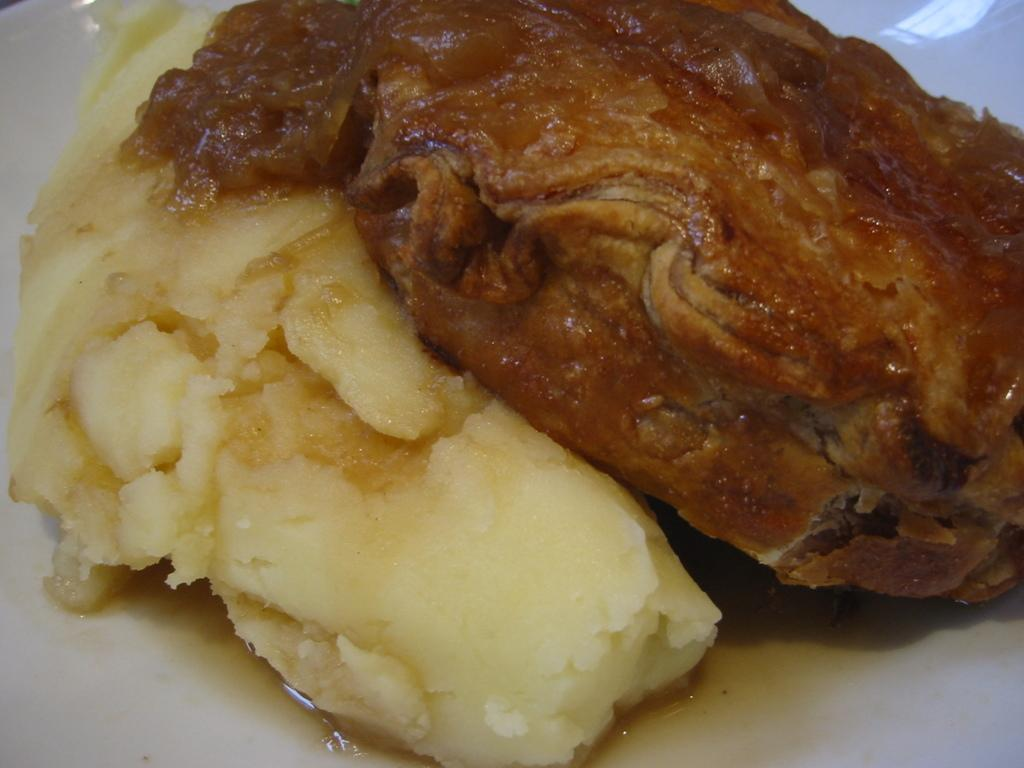What types of food can be seen in the image? There are food items in the image, but their specific types cannot be determined from the provided facts. What color is the plate on which the food items are placed? The plate is white in color. What colors can be observed in the food items? The food has brown and cream colors. What type of disease is being treated in the image? There is no indication of a disease or any medical treatment in the image. Can you describe the railway system visible in the image? There is no railway system present in the image. 